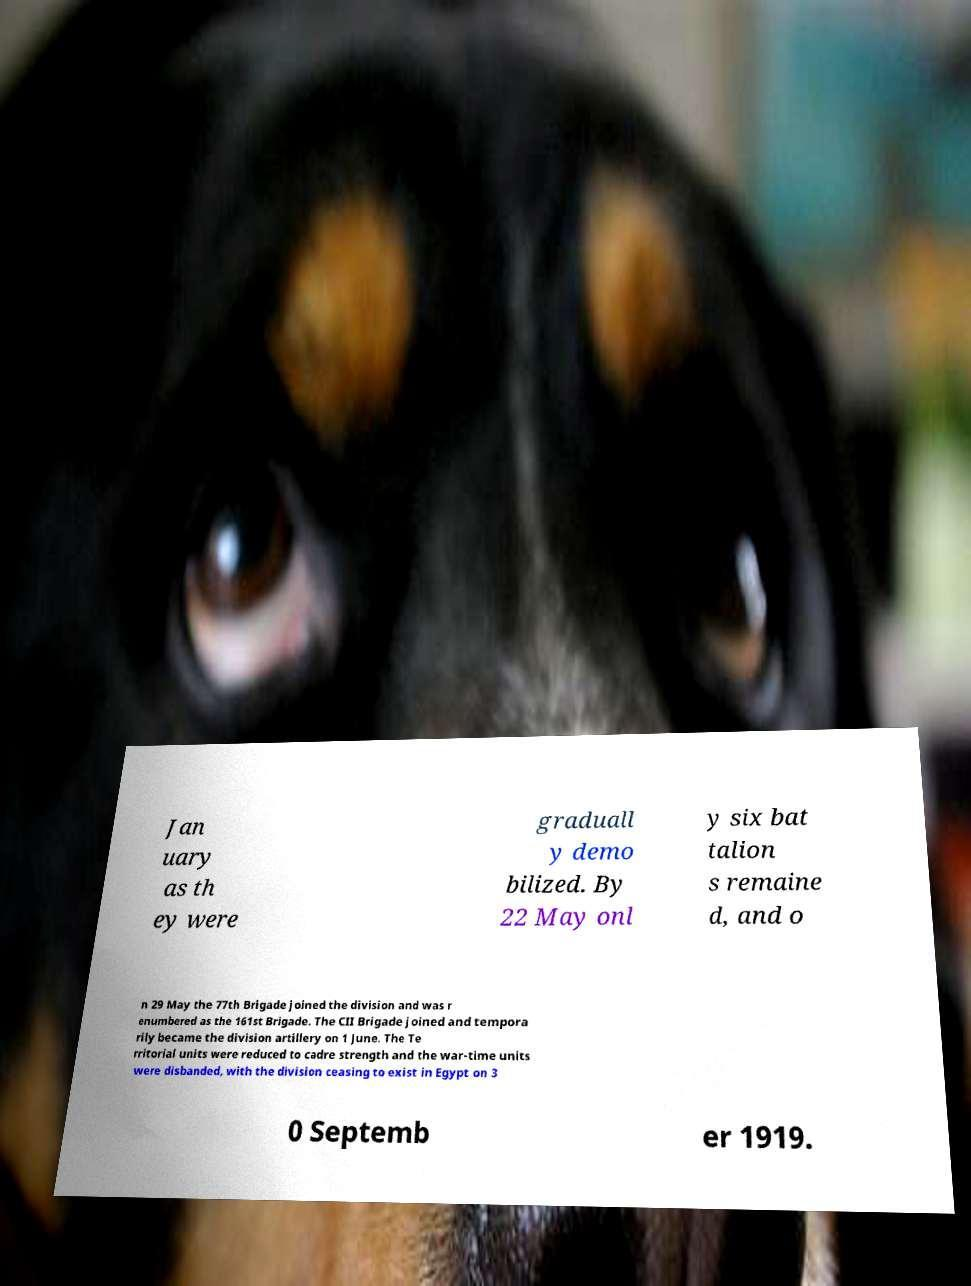Could you extract and type out the text from this image? Jan uary as th ey were graduall y demo bilized. By 22 May onl y six bat talion s remaine d, and o n 29 May the 77th Brigade joined the division and was r enumbered as the 161st Brigade. The CII Brigade joined and tempora rily became the division artillery on 1 June. The Te rritorial units were reduced to cadre strength and the war-time units were disbanded, with the division ceasing to exist in Egypt on 3 0 Septemb er 1919. 